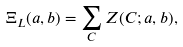<formula> <loc_0><loc_0><loc_500><loc_500>\Xi _ { L } ( a , b ) = \sum _ { C } Z ( C ; a , b ) ,</formula> 